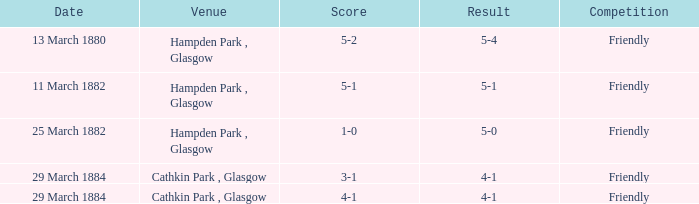Which item resulted in a score of 4-1? 3-1, 4-1. Help me parse the entirety of this table. {'header': ['Date', 'Venue', 'Score', 'Result', 'Competition'], 'rows': [['13 March 1880', 'Hampden Park , Glasgow', '5-2', '5-4', 'Friendly'], ['11 March 1882', 'Hampden Park , Glasgow', '5-1', '5-1', 'Friendly'], ['25 March 1882', 'Hampden Park , Glasgow', '1-0', '5-0', 'Friendly'], ['29 March 1884', 'Cathkin Park , Glasgow', '3-1', '4-1', 'Friendly'], ['29 March 1884', 'Cathkin Park , Glasgow', '4-1', '4-1', 'Friendly']]} 